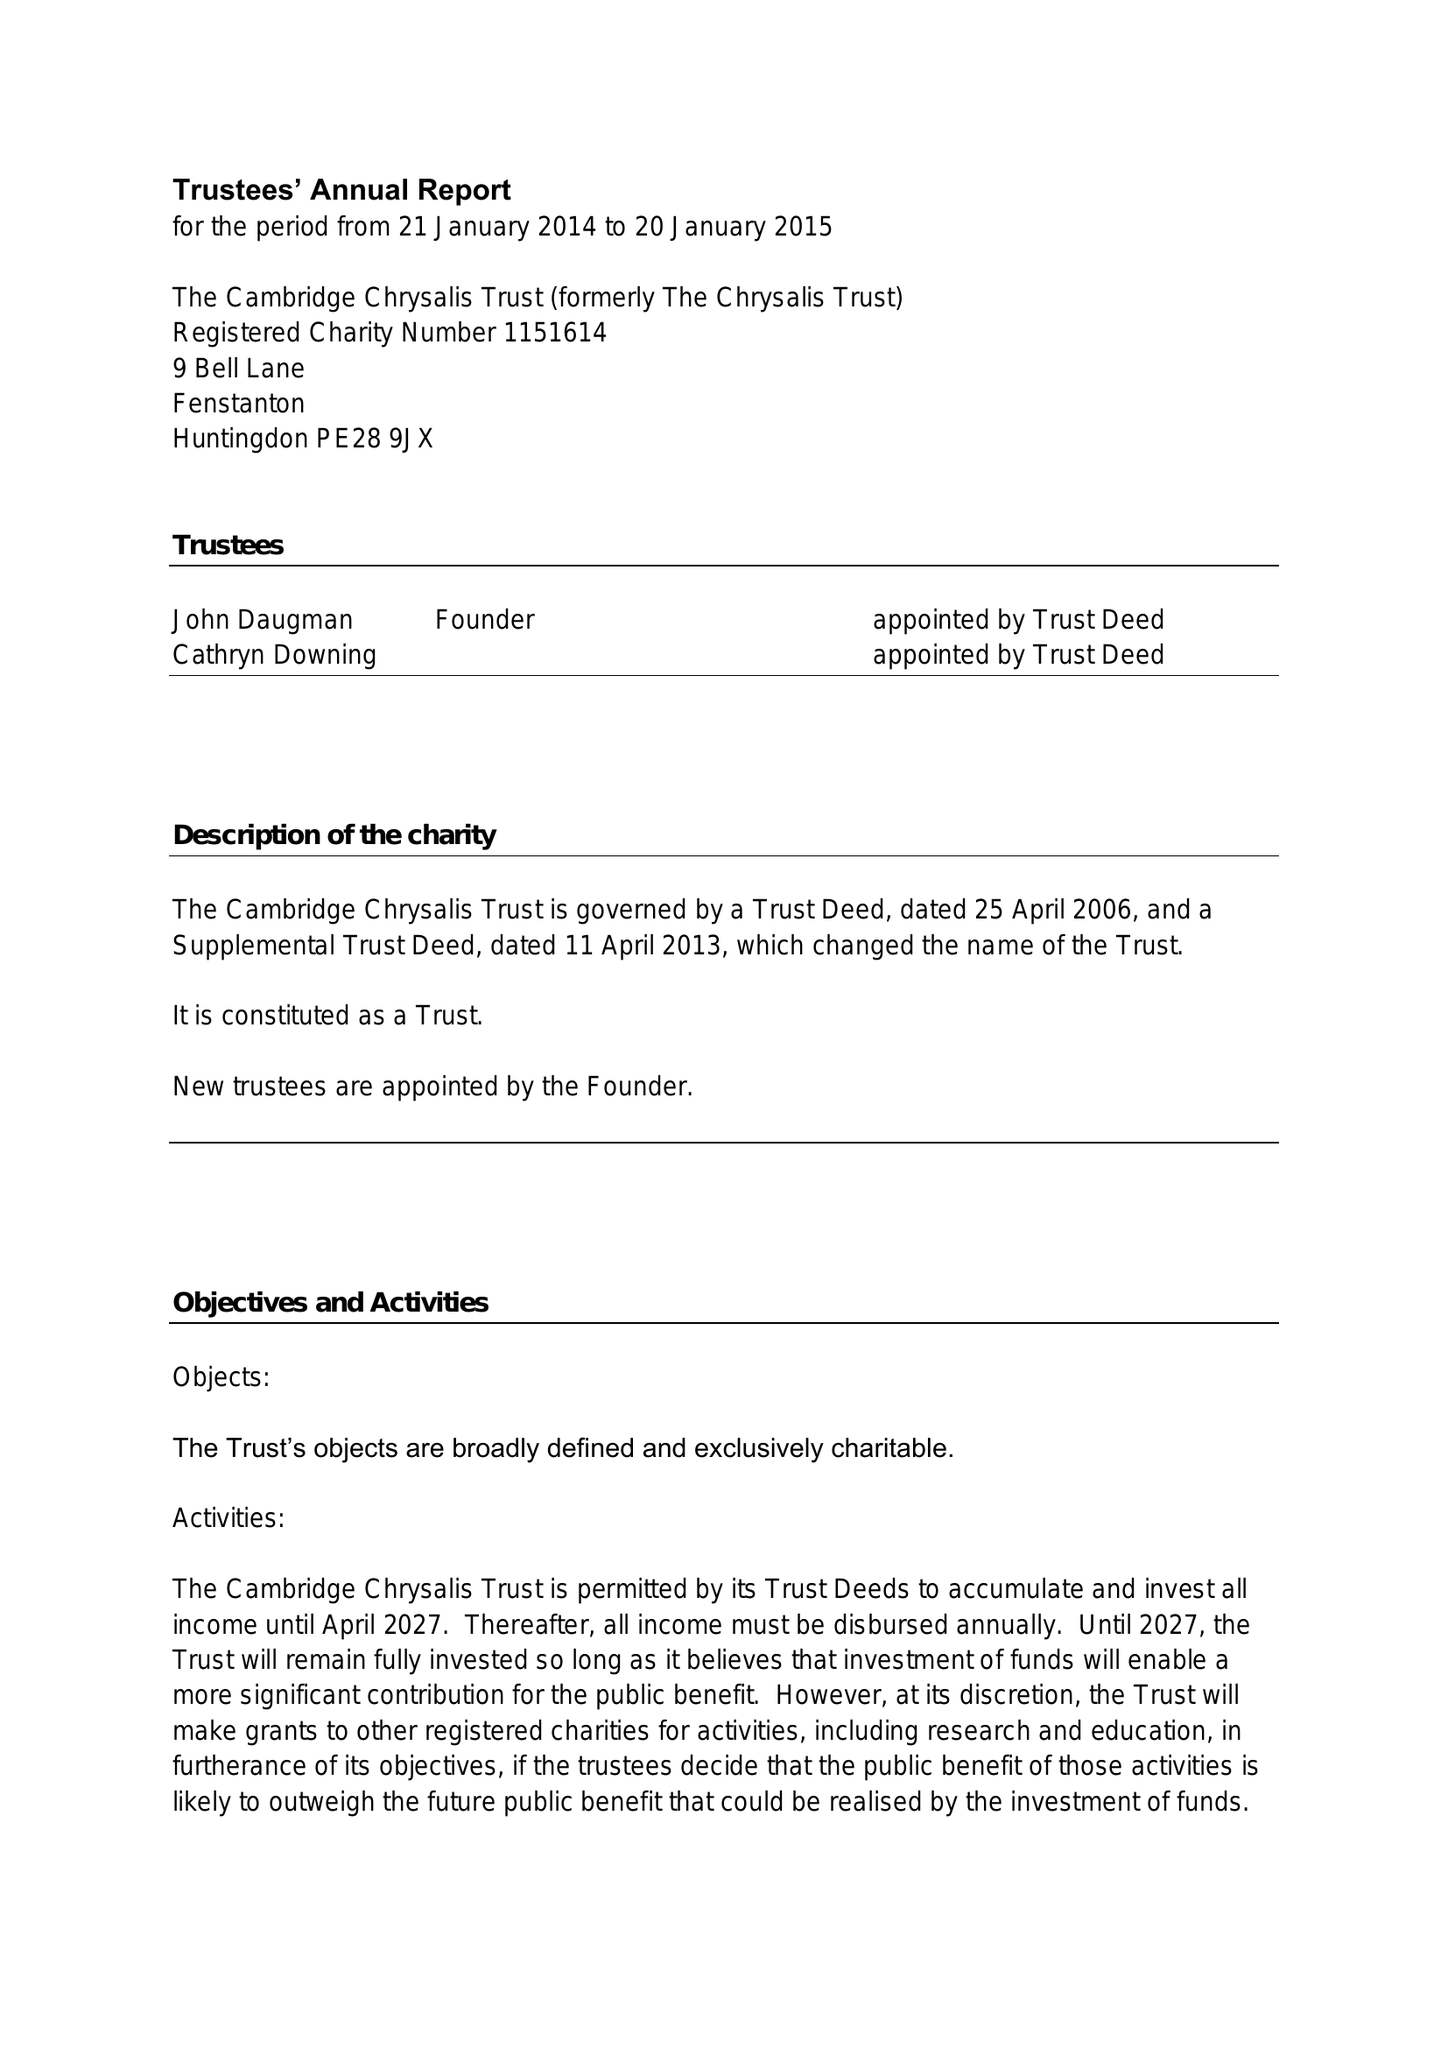What is the value for the report_date?
Answer the question using a single word or phrase. 2015-01-20 